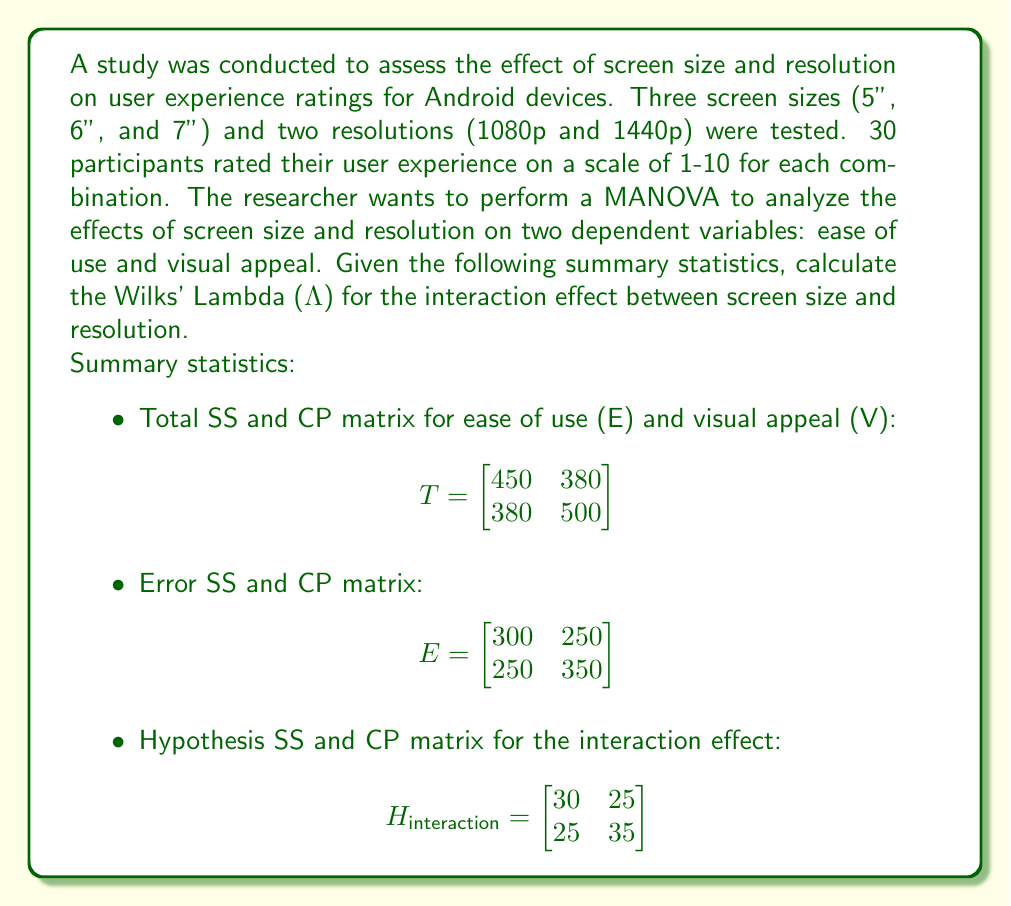Can you answer this question? To calculate Wilks' Lambda (Λ) for the interaction effect, we need to follow these steps:

1. Calculate the determinant of the Error matrix (E):
   $$ |E| = (300 \times 350) - (250 \times 250) = 105000 - 62500 = 42500 $$

2. Calculate the determinant of the sum of Error and Hypothesis matrices (E + H):
   $$ |E + H_{interaction}| = |(300+30, 250+25; 250+25, 350+35)| $$
   $$ = |(330, 275; 275, 385)| $$
   $$ = (330 \times 385) - (275 \times 275) = 127050 - 75625 = 51425 $$

3. Calculate Wilks' Lambda using the formula:
   $$ \Lambda = \frac{|E|}{|E + H|} $$

   $$ \Lambda = \frac{42500}{51425} $$

4. Simplify the fraction:
   $$ \Lambda = \frac{850}{1028.5} $$

   $$ \Lambda \approx 0.8265 $$

The Wilks' Lambda value ranges from 0 to 1, where values closer to 0 indicate a stronger effect, and values closer to 1 indicate a weaker effect. In this case, the Wilks' Lambda of approximately 0.8265 suggests a moderate to weak interaction effect between screen size and resolution on the user experience ratings (ease of use and visual appeal).
Answer: $$ \Lambda \approx 0.8265 $$ 